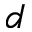Convert formula to latex. <formula><loc_0><loc_0><loc_500><loc_500>d</formula> 